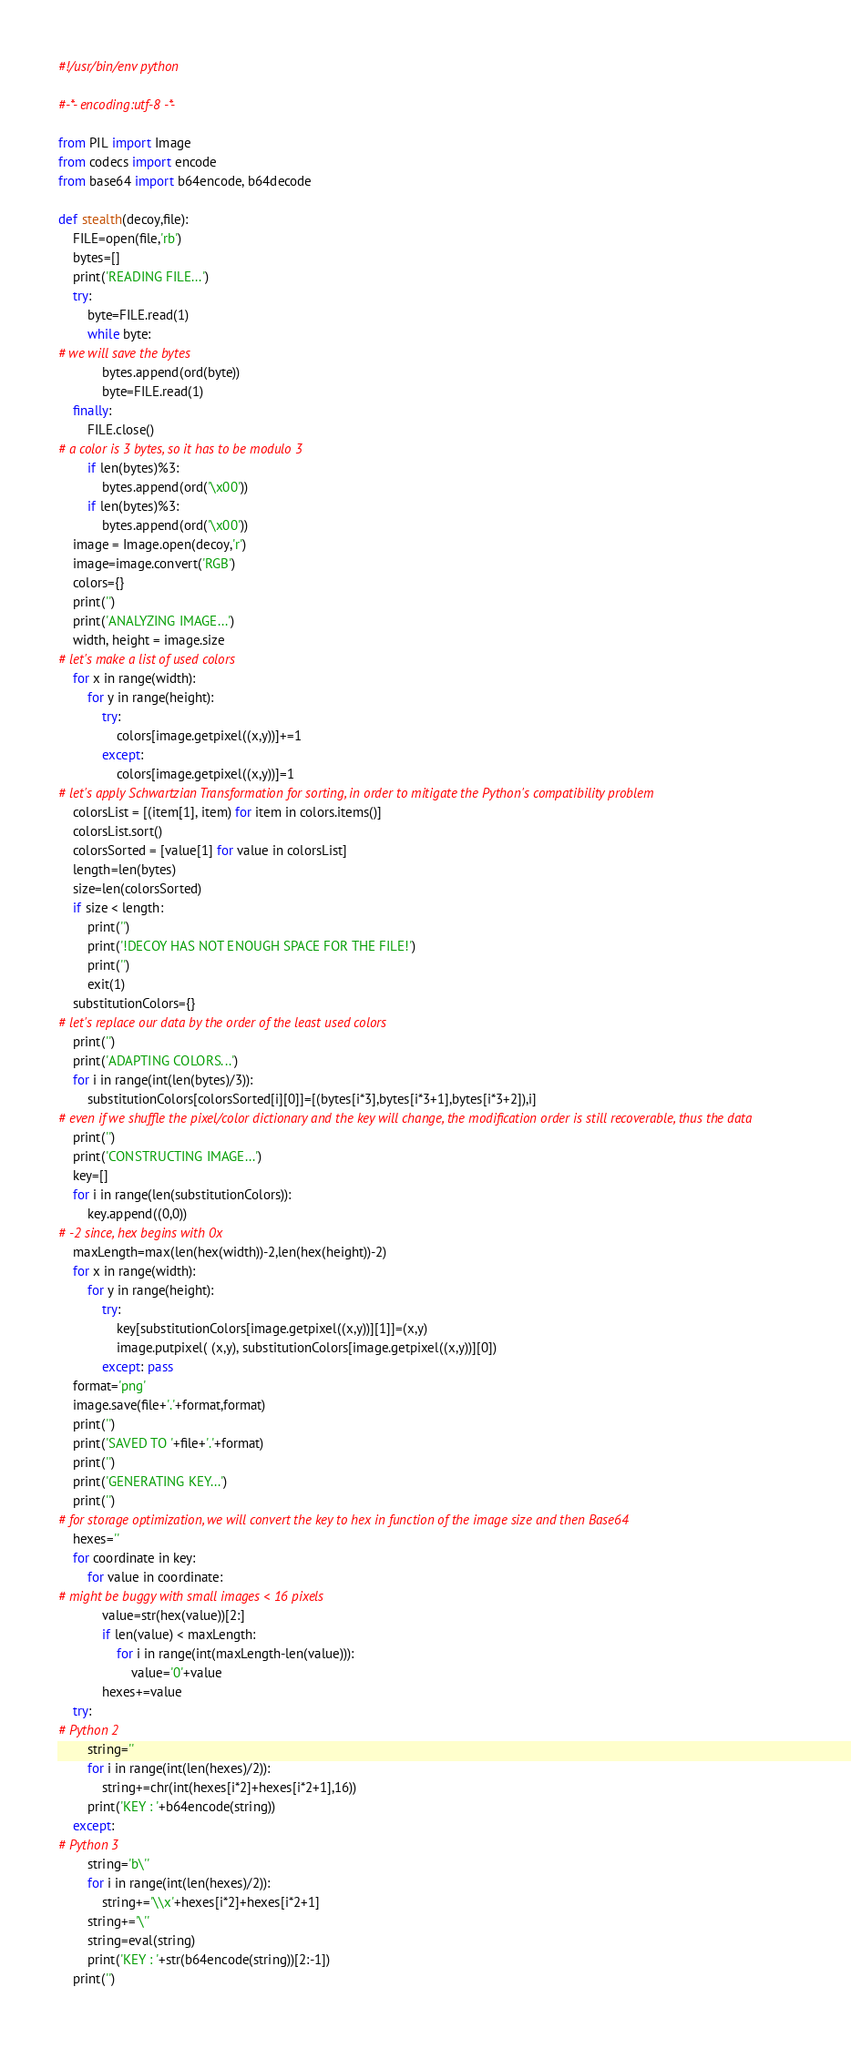Convert code to text. <code><loc_0><loc_0><loc_500><loc_500><_Python_>#!/usr/bin/env python

#-*- encoding:utf-8 -*-

from PIL import Image
from codecs import encode
from base64 import b64encode, b64decode

def stealth(decoy,file):
	FILE=open(file,'rb')
	bytes=[]
	print('READING FILE...')
	try:
		byte=FILE.read(1)
		while byte:
# we will save the bytes
			bytes.append(ord(byte))
			byte=FILE.read(1)
	finally:
		FILE.close()
# a color is 3 bytes, so it has to be modulo 3
		if len(bytes)%3:
			bytes.append(ord('\x00'))
		if len(bytes)%3:
			bytes.append(ord('\x00'))
	image = Image.open(decoy,'r')
	image=image.convert('RGB')
	colors={}
	print('')
	print('ANALYZING IMAGE...')
	width, height = image.size
# let's make a list of used colors
	for x in range(width):
		for y in range(height):
			try:
				colors[image.getpixel((x,y))]+=1
			except:
				colors[image.getpixel((x,y))]=1
# let's apply Schwartzian Transformation for sorting, in order to mitigate the Python's compatibility problem
	colorsList = [(item[1], item) for item in colors.items()]
	colorsList.sort()
	colorsSorted = [value[1] for value in colorsList]
	length=len(bytes)
	size=len(colorsSorted)
	if size < length:
		print('')
		print('!DECOY HAS NOT ENOUGH SPACE FOR THE FILE!')
		print('')
		exit(1)
	substitutionColors={}
# let's replace our data by the order of the least used colors
	print('')
	print('ADAPTING COLORS...')
	for i in range(int(len(bytes)/3)):
		substitutionColors[colorsSorted[i][0]]=[(bytes[i*3],bytes[i*3+1],bytes[i*3+2]),i]
# even if we shuffle the pixel/color dictionary and the key will change, the modification order is still recoverable, thus the data
	print('')
	print('CONSTRUCTING IMAGE...')
	key=[]
	for i in range(len(substitutionColors)):
		key.append((0,0))
# -2 since, hex begins with 0x
	maxLength=max(len(hex(width))-2,len(hex(height))-2)
	for x in range(width):
		for y in range(height):
			try:
				key[substitutionColors[image.getpixel((x,y))][1]]=(x,y)
				image.putpixel( (x,y), substitutionColors[image.getpixel((x,y))][0])
			except: pass
	format='png'
	image.save(file+'.'+format,format)
	print('')
	print('SAVED TO '+file+'.'+format)
	print('')
	print('GENERATING KEY...')
	print('')
# for storage optimization, we will convert the key to hex in function of the image size and then Base64
	hexes=''
	for coordinate in key:
		for value in coordinate:
# might be buggy with small images < 16 pixels
			value=str(hex(value))[2:]
			if len(value) < maxLength:
				for i in range(int(maxLength-len(value))):
					value='0'+value
			hexes+=value
	try:
# Python 2
		string=''
		for i in range(int(len(hexes)/2)):
			string+=chr(int(hexes[i*2]+hexes[i*2+1],16))
		print('KEY : '+b64encode(string))
	except:
# Python 3
		string='b\''
		for i in range(int(len(hexes)/2)):
			string+='\\x'+hexes[i*2]+hexes[i*2+1]
		string+='\''
		string=eval(string)
		print('KEY : '+str(b64encode(string))[2:-1])
	print('')
</code> 